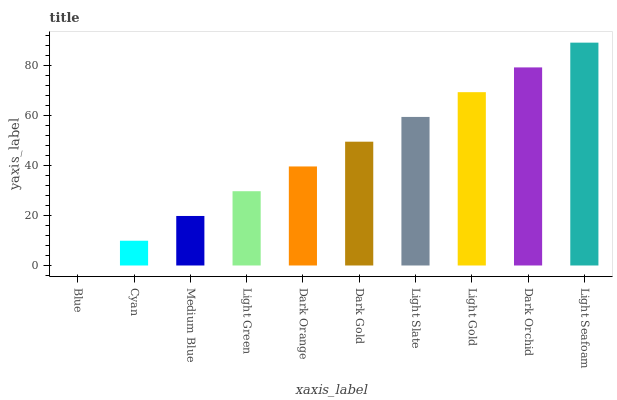Is Blue the minimum?
Answer yes or no. Yes. Is Light Seafoam the maximum?
Answer yes or no. Yes. Is Cyan the minimum?
Answer yes or no. No. Is Cyan the maximum?
Answer yes or no. No. Is Cyan greater than Blue?
Answer yes or no. Yes. Is Blue less than Cyan?
Answer yes or no. Yes. Is Blue greater than Cyan?
Answer yes or no. No. Is Cyan less than Blue?
Answer yes or no. No. Is Dark Gold the high median?
Answer yes or no. Yes. Is Dark Orange the low median?
Answer yes or no. Yes. Is Medium Blue the high median?
Answer yes or no. No. Is Blue the low median?
Answer yes or no. No. 